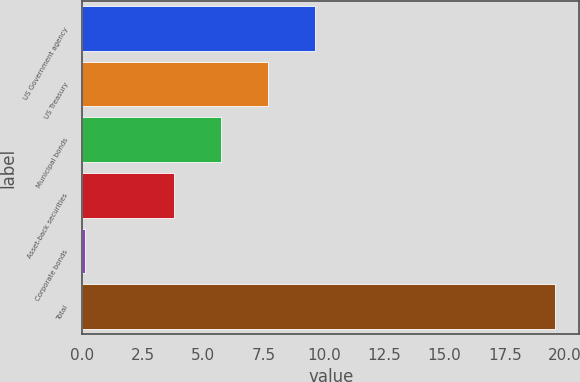<chart> <loc_0><loc_0><loc_500><loc_500><bar_chart><fcel>US Government agency<fcel>US Treasury<fcel>Municipal bonds<fcel>Asset-back securities<fcel>Corporate bonds<fcel>Total<nl><fcel>9.65<fcel>7.7<fcel>5.75<fcel>3.8<fcel>0.1<fcel>19.6<nl></chart> 